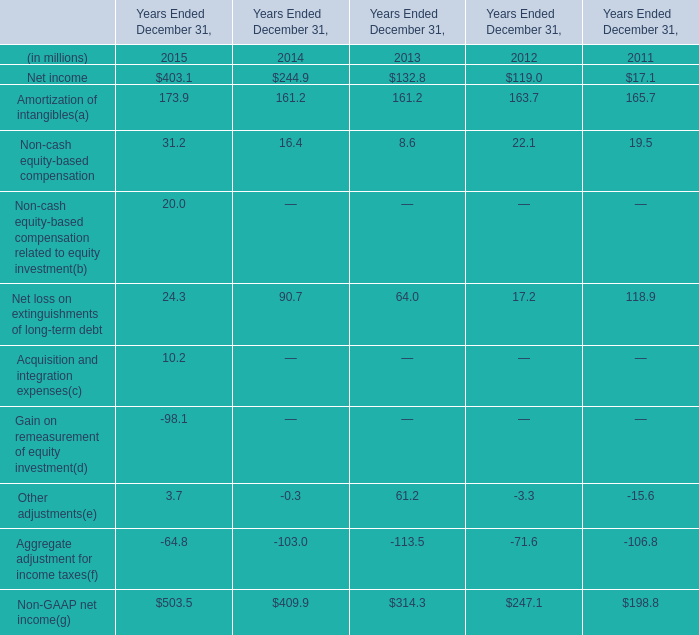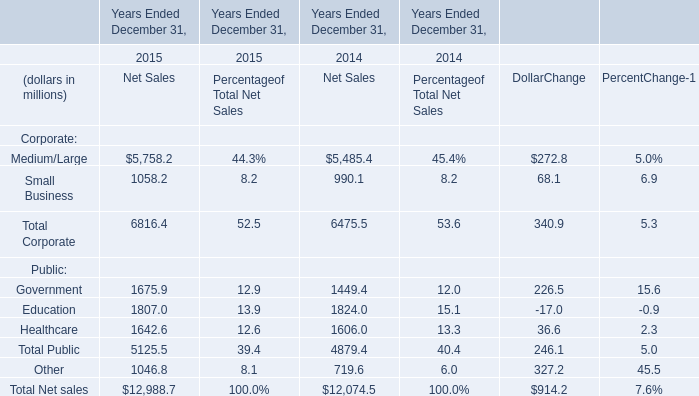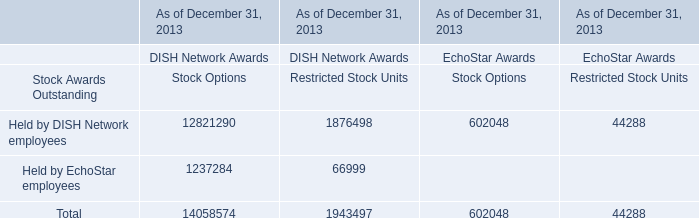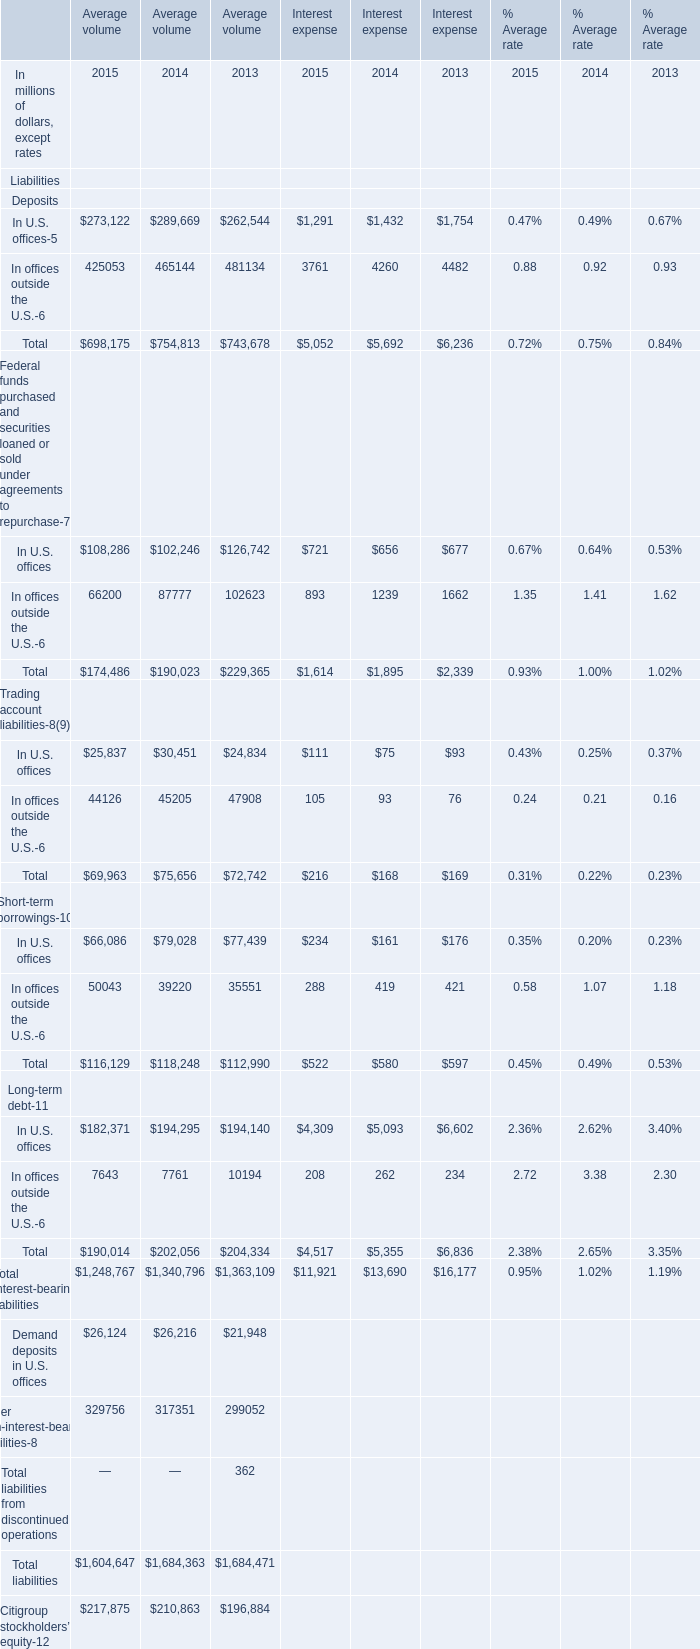What is the sum of Medium/Large of Years Ended December 31, 2015 Net Sales, and In offices outside the U.S. of Interest expense 2013 ? 
Computations: (5758.2 + 4482.0)
Answer: 10240.2. 